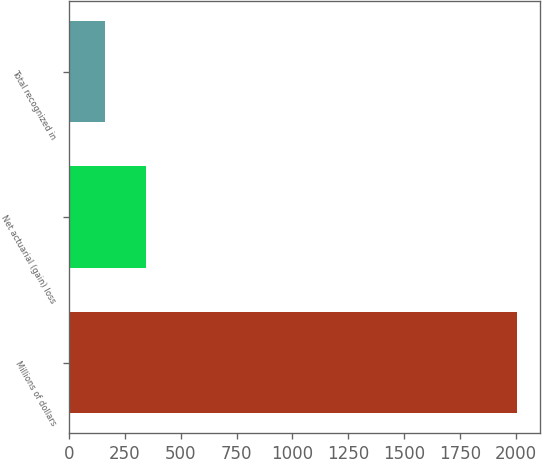Convert chart to OTSL. <chart><loc_0><loc_0><loc_500><loc_500><bar_chart><fcel>Millions of dollars<fcel>Net actuarial (gain) loss<fcel>Total recognized in<nl><fcel>2008<fcel>343.9<fcel>159<nl></chart> 